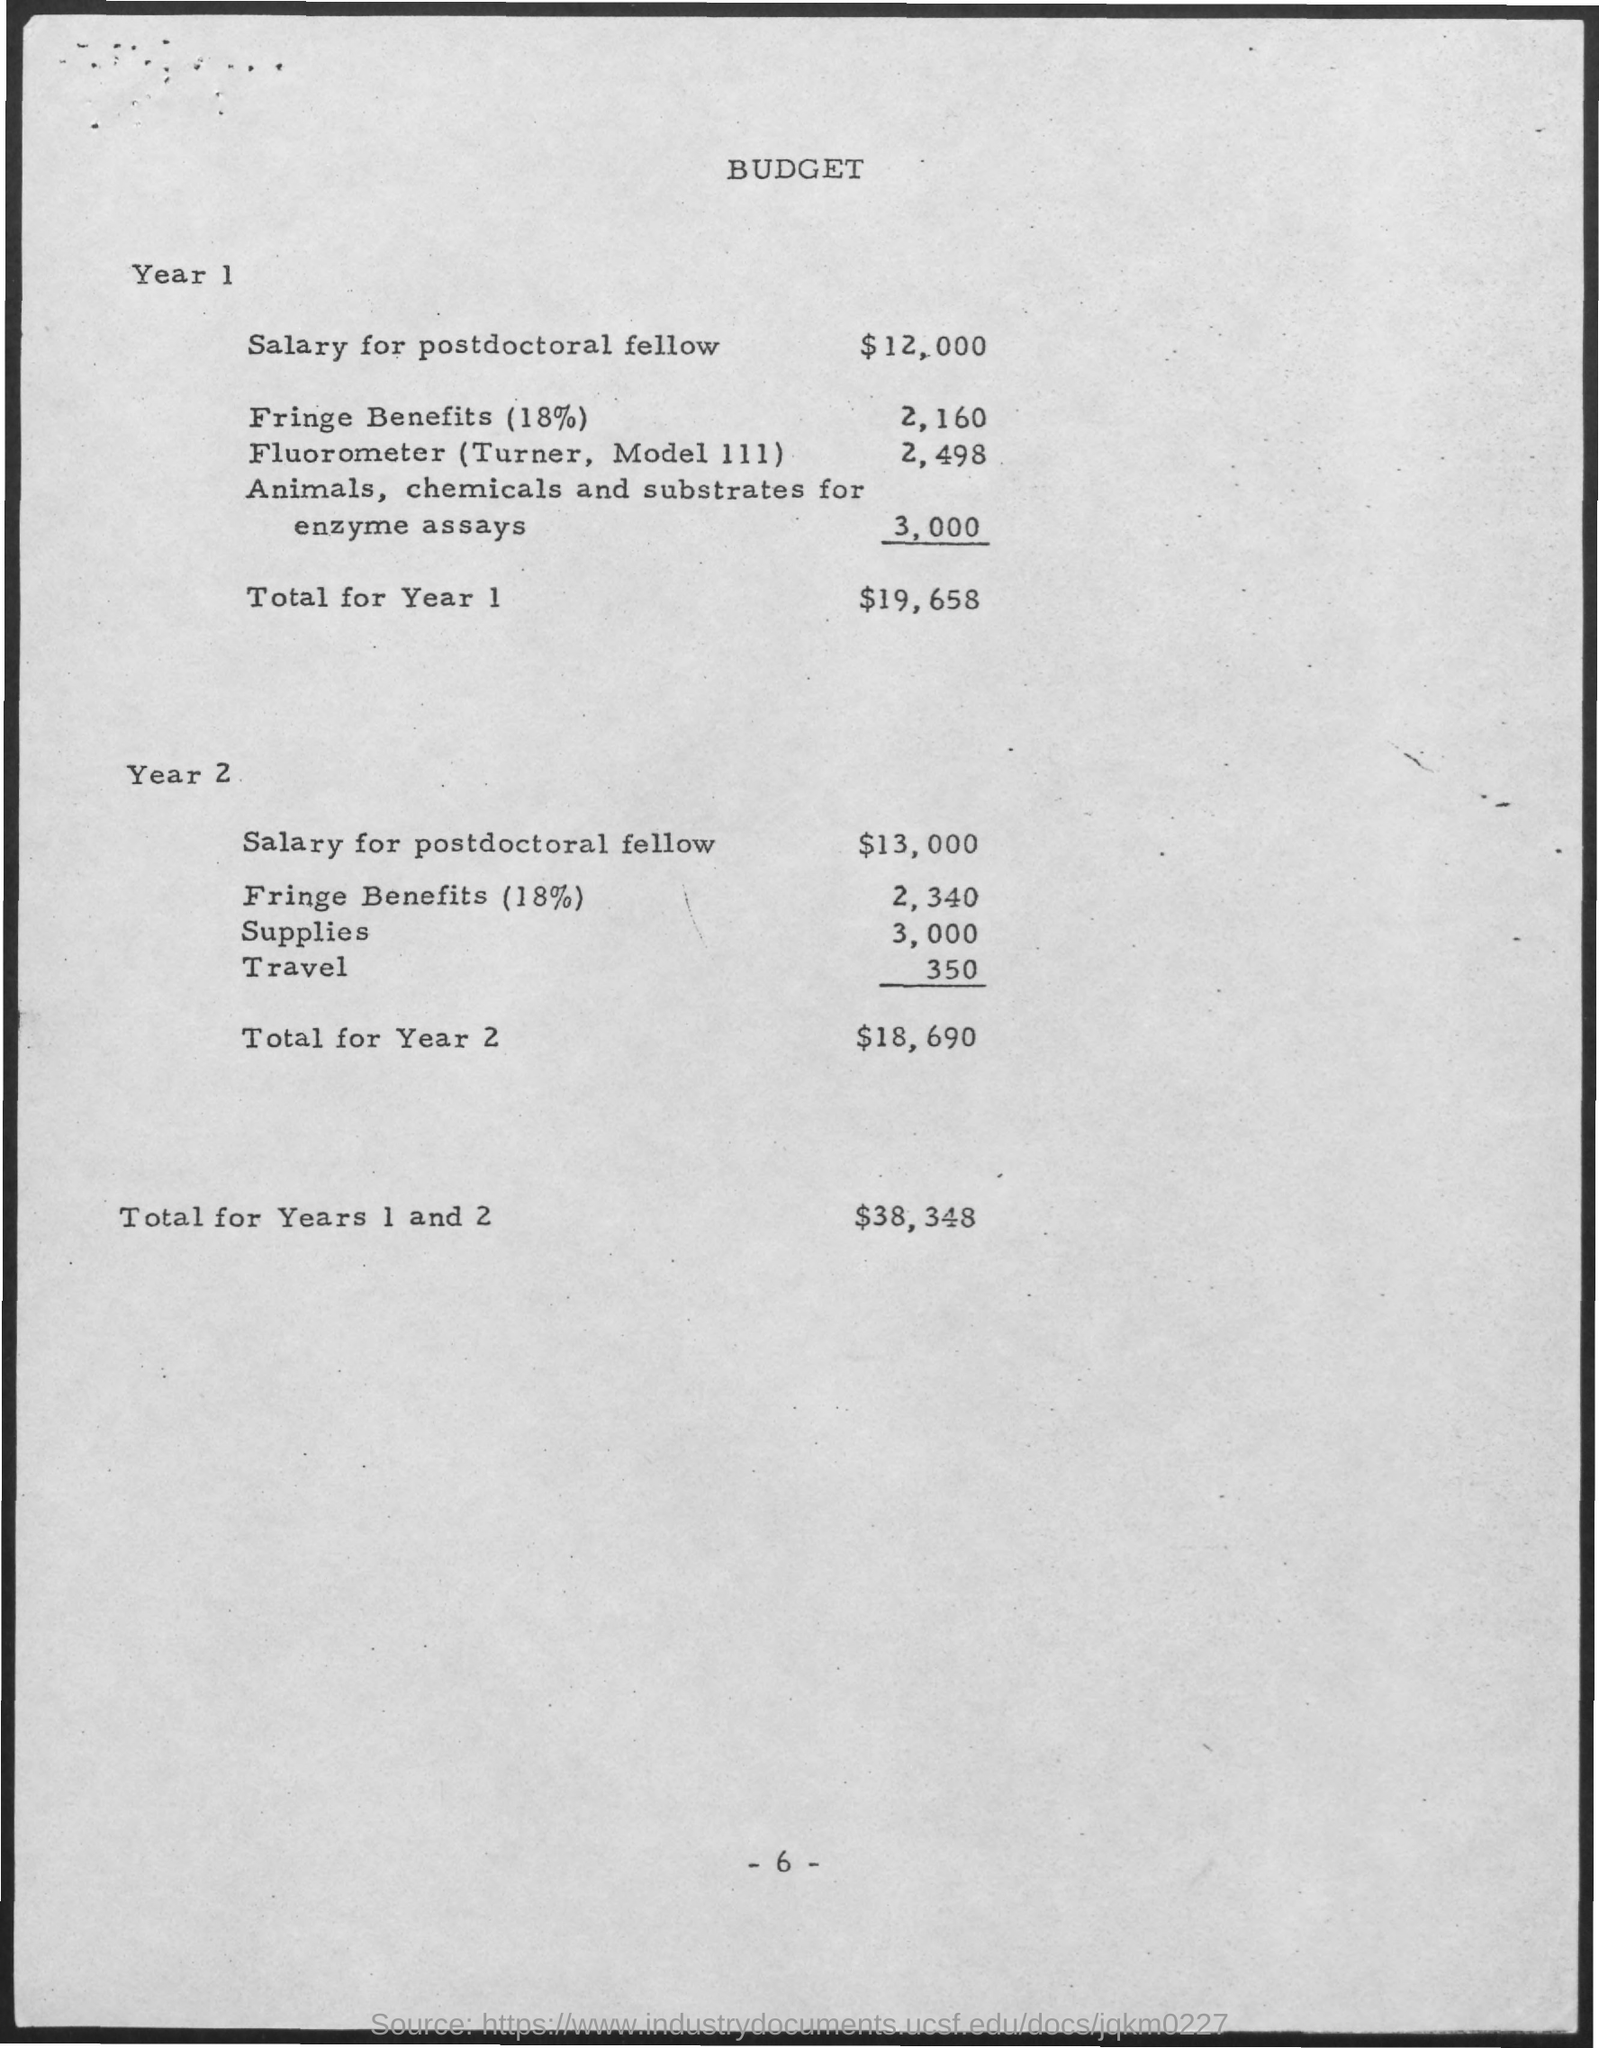What is the Salary for postdoctoral fellow for Year 1?
Offer a very short reply. $12,000. What is the Salary for postdoctoral fellow for Year 2?
Give a very brief answer. $13,000. Whta is the Fringe Benefits (18%) for Year 1?
Your response must be concise. 2,160. Whta is the Fringe Benefits (18%) for Year 2?
Offer a very short reply. 2,340. What is the Supplies for Year 2?
Offer a very short reply. 3,000. What is the Total for Year 1?
Provide a succinct answer. $19,658. What is the Total for Year 2?
Keep it short and to the point. $18,690. What is the Total for Years 1 and 2?
Make the answer very short. $38,348. What is the Travel Expense  for Year 2?
Give a very brief answer. 350. 